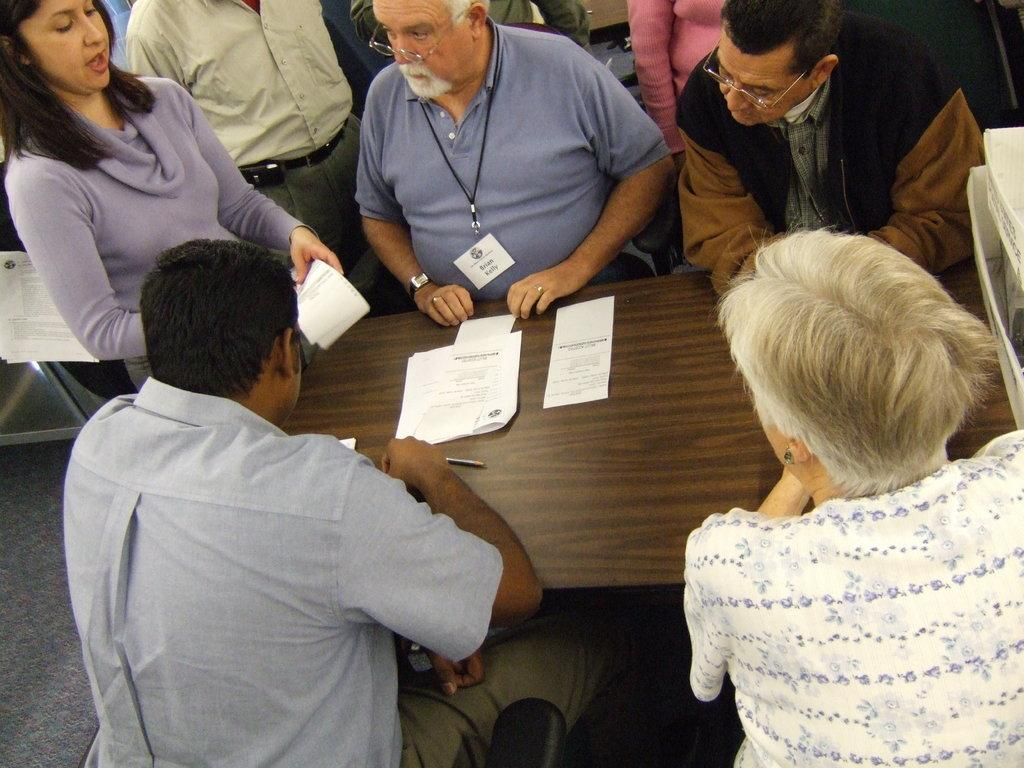What are the people in the image doing? There are people sitting and standing in the image. What is the woman holding in the image? The woman is holding papers in the image. What else can be seen on the table in the image? There are papers and a pencil on the table in the image. Where is the market located in the image? There is no market present in the image. What type of iron is being used by the people in the image? There is no iron present in the image. 